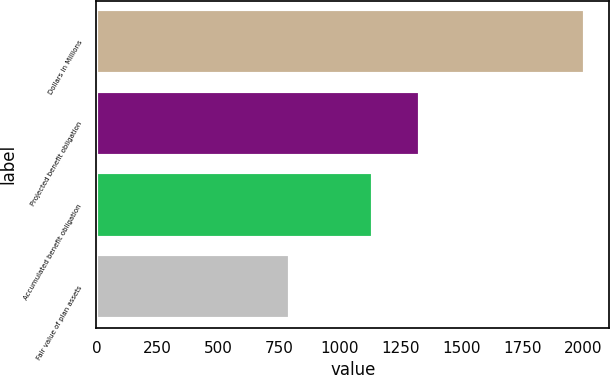Convert chart to OTSL. <chart><loc_0><loc_0><loc_500><loc_500><bar_chart><fcel>Dollars in Millions<fcel>Projected benefit obligation<fcel>Accumulated benefit obligation<fcel>Fair value of plan assets<nl><fcel>2006<fcel>1328<fcel>1137<fcel>795<nl></chart> 